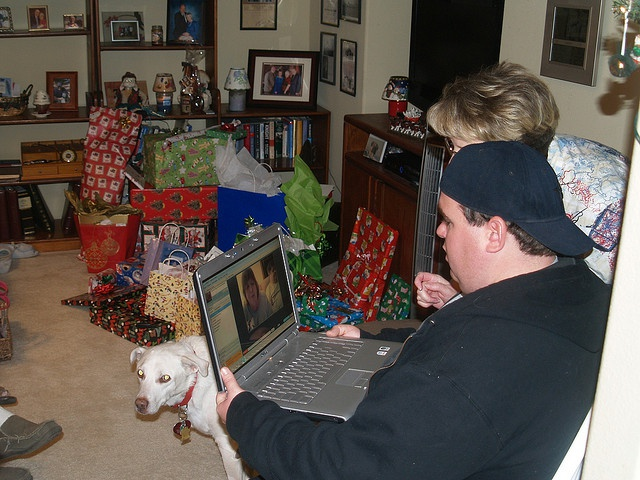Describe the objects in this image and their specific colors. I can see people in gray, black, and lightpink tones, laptop in gray, black, and darkgray tones, people in gray, lightgray, black, and darkgray tones, dog in gray, lightgray, and darkgray tones, and book in gray, black, and maroon tones in this image. 